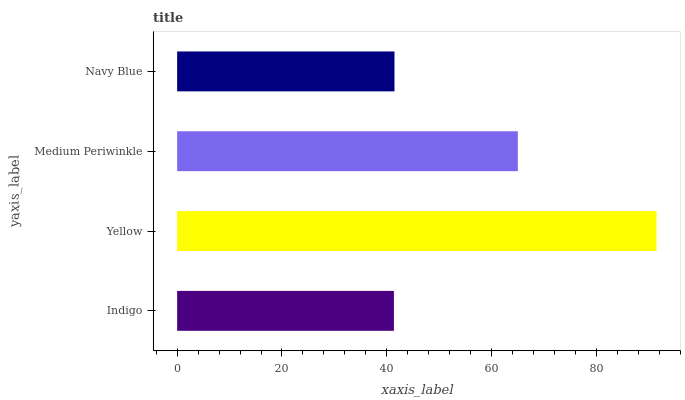Is Indigo the minimum?
Answer yes or no. Yes. Is Yellow the maximum?
Answer yes or no. Yes. Is Medium Periwinkle the minimum?
Answer yes or no. No. Is Medium Periwinkle the maximum?
Answer yes or no. No. Is Yellow greater than Medium Periwinkle?
Answer yes or no. Yes. Is Medium Periwinkle less than Yellow?
Answer yes or no. Yes. Is Medium Periwinkle greater than Yellow?
Answer yes or no. No. Is Yellow less than Medium Periwinkle?
Answer yes or no. No. Is Medium Periwinkle the high median?
Answer yes or no. Yes. Is Navy Blue the low median?
Answer yes or no. Yes. Is Yellow the high median?
Answer yes or no. No. Is Medium Periwinkle the low median?
Answer yes or no. No. 